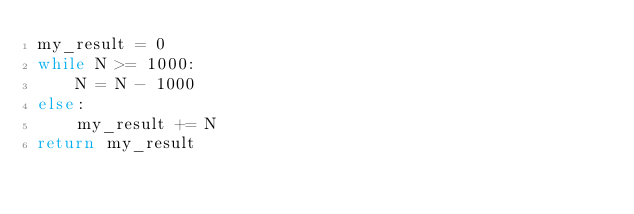<code> <loc_0><loc_0><loc_500><loc_500><_Python_>my_result = 0
while N >= 1000:
    N = N - 1000
else:
    my_result += N
return my_result</code> 